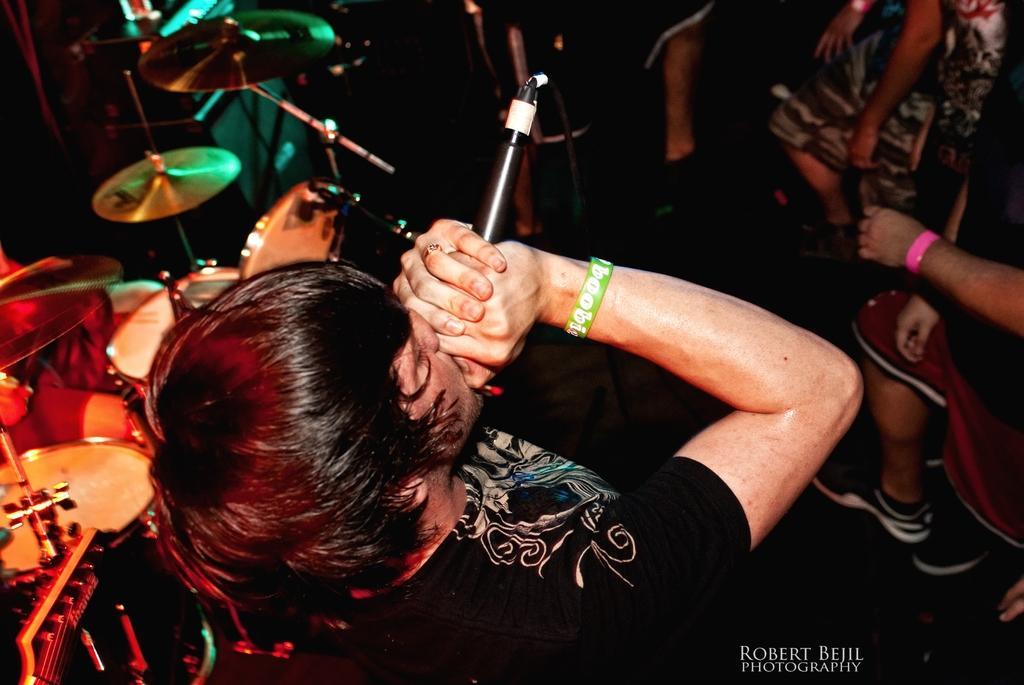How would you summarize this image in a sentence or two? This is the picture taken on a stage, a man in black t shirt was holding a microphone and singing a song. In front of the man there are group of people standing on the floor. behind the people there are some music instruments and a cymbal. 